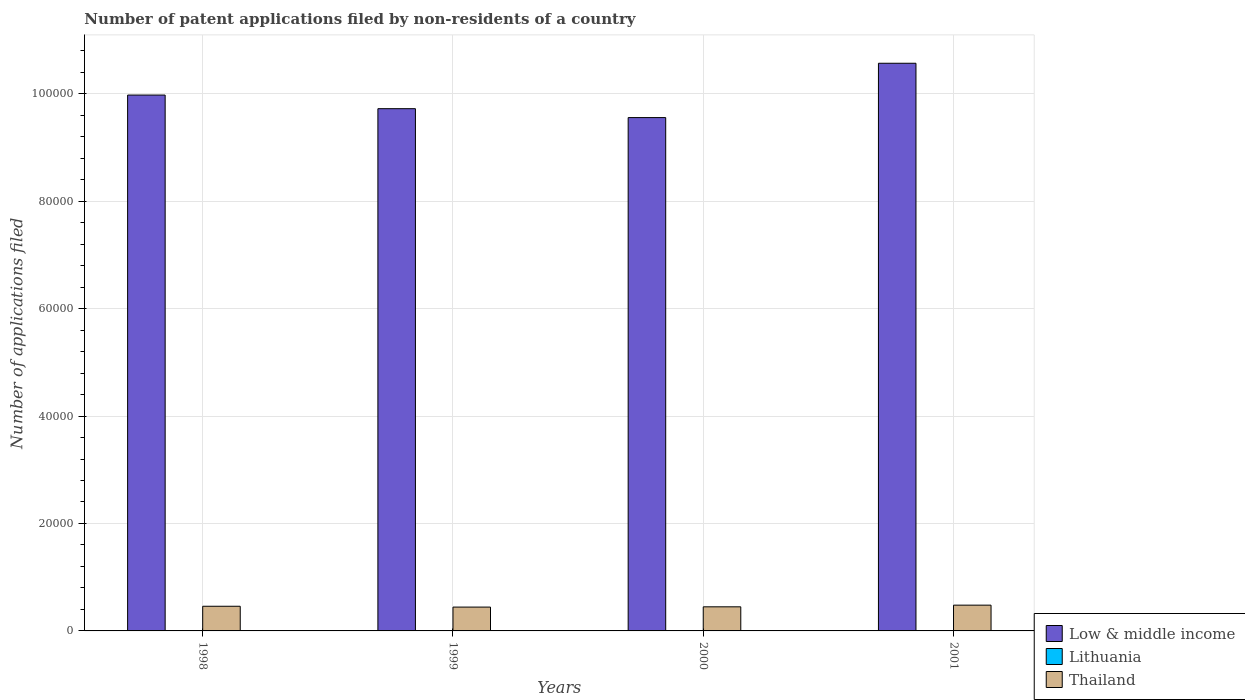How many different coloured bars are there?
Give a very brief answer. 3. What is the label of the 1st group of bars from the left?
Your answer should be very brief. 1998. What is the number of applications filed in Lithuania in 1999?
Your answer should be compact. 71. Across all years, what is the minimum number of applications filed in Low & middle income?
Give a very brief answer. 9.56e+04. In which year was the number of applications filed in Thailand minimum?
Keep it short and to the point. 1999. What is the total number of applications filed in Low & middle income in the graph?
Offer a terse response. 3.98e+05. What is the difference between the number of applications filed in Low & middle income in 1998 and that in 2000?
Offer a terse response. 4195. What is the difference between the number of applications filed in Lithuania in 2000 and the number of applications filed in Low & middle income in 2001?
Make the answer very short. -1.06e+05. What is the average number of applications filed in Thailand per year?
Make the answer very short. 4579. In the year 1999, what is the difference between the number of applications filed in Thailand and number of applications filed in Low & middle income?
Ensure brevity in your answer.  -9.28e+04. What is the ratio of the number of applications filed in Thailand in 1999 to that in 2000?
Offer a terse response. 0.99. Is the number of applications filed in Thailand in 1998 less than that in 2001?
Keep it short and to the point. Yes. Is the difference between the number of applications filed in Thailand in 1998 and 1999 greater than the difference between the number of applications filed in Low & middle income in 1998 and 1999?
Ensure brevity in your answer.  No. In how many years, is the number of applications filed in Thailand greater than the average number of applications filed in Thailand taken over all years?
Your answer should be compact. 2. Is the sum of the number of applications filed in Thailand in 1999 and 2000 greater than the maximum number of applications filed in Lithuania across all years?
Provide a short and direct response. Yes. What does the 2nd bar from the right in 1998 represents?
Offer a very short reply. Lithuania. Are all the bars in the graph horizontal?
Provide a short and direct response. No. Are the values on the major ticks of Y-axis written in scientific E-notation?
Provide a short and direct response. No. Does the graph contain any zero values?
Provide a succinct answer. No. Does the graph contain grids?
Provide a succinct answer. Yes. How many legend labels are there?
Provide a succinct answer. 3. What is the title of the graph?
Offer a very short reply. Number of patent applications filed by non-residents of a country. What is the label or title of the Y-axis?
Keep it short and to the point. Number of applications filed. What is the Number of applications filed of Low & middle income in 1998?
Your answer should be compact. 9.98e+04. What is the Number of applications filed in Lithuania in 1998?
Your answer should be compact. 71. What is the Number of applications filed of Thailand in 1998?
Your answer should be very brief. 4592. What is the Number of applications filed in Low & middle income in 1999?
Offer a terse response. 9.72e+04. What is the Number of applications filed of Thailand in 1999?
Provide a short and direct response. 4438. What is the Number of applications filed in Low & middle income in 2000?
Provide a succinct answer. 9.56e+04. What is the Number of applications filed in Lithuania in 2000?
Provide a short and direct response. 61. What is the Number of applications filed in Thailand in 2000?
Offer a terse response. 4488. What is the Number of applications filed in Low & middle income in 2001?
Your answer should be compact. 1.06e+05. What is the Number of applications filed in Lithuania in 2001?
Give a very brief answer. 55. What is the Number of applications filed of Thailand in 2001?
Keep it short and to the point. 4798. Across all years, what is the maximum Number of applications filed in Low & middle income?
Your answer should be compact. 1.06e+05. Across all years, what is the maximum Number of applications filed in Thailand?
Offer a terse response. 4798. Across all years, what is the minimum Number of applications filed of Low & middle income?
Provide a succinct answer. 9.56e+04. Across all years, what is the minimum Number of applications filed in Thailand?
Give a very brief answer. 4438. What is the total Number of applications filed in Low & middle income in the graph?
Your answer should be very brief. 3.98e+05. What is the total Number of applications filed of Lithuania in the graph?
Make the answer very short. 258. What is the total Number of applications filed in Thailand in the graph?
Provide a succinct answer. 1.83e+04. What is the difference between the Number of applications filed in Low & middle income in 1998 and that in 1999?
Make the answer very short. 2538. What is the difference between the Number of applications filed of Lithuania in 1998 and that in 1999?
Your answer should be very brief. 0. What is the difference between the Number of applications filed of Thailand in 1998 and that in 1999?
Give a very brief answer. 154. What is the difference between the Number of applications filed of Low & middle income in 1998 and that in 2000?
Provide a short and direct response. 4195. What is the difference between the Number of applications filed of Lithuania in 1998 and that in 2000?
Give a very brief answer. 10. What is the difference between the Number of applications filed in Thailand in 1998 and that in 2000?
Provide a short and direct response. 104. What is the difference between the Number of applications filed in Low & middle income in 1998 and that in 2001?
Provide a short and direct response. -5919. What is the difference between the Number of applications filed in Lithuania in 1998 and that in 2001?
Your answer should be very brief. 16. What is the difference between the Number of applications filed of Thailand in 1998 and that in 2001?
Your response must be concise. -206. What is the difference between the Number of applications filed in Low & middle income in 1999 and that in 2000?
Offer a very short reply. 1657. What is the difference between the Number of applications filed in Low & middle income in 1999 and that in 2001?
Keep it short and to the point. -8457. What is the difference between the Number of applications filed in Thailand in 1999 and that in 2001?
Your response must be concise. -360. What is the difference between the Number of applications filed in Low & middle income in 2000 and that in 2001?
Offer a very short reply. -1.01e+04. What is the difference between the Number of applications filed in Thailand in 2000 and that in 2001?
Provide a short and direct response. -310. What is the difference between the Number of applications filed in Low & middle income in 1998 and the Number of applications filed in Lithuania in 1999?
Provide a short and direct response. 9.97e+04. What is the difference between the Number of applications filed of Low & middle income in 1998 and the Number of applications filed of Thailand in 1999?
Offer a very short reply. 9.53e+04. What is the difference between the Number of applications filed in Lithuania in 1998 and the Number of applications filed in Thailand in 1999?
Ensure brevity in your answer.  -4367. What is the difference between the Number of applications filed of Low & middle income in 1998 and the Number of applications filed of Lithuania in 2000?
Offer a terse response. 9.97e+04. What is the difference between the Number of applications filed of Low & middle income in 1998 and the Number of applications filed of Thailand in 2000?
Make the answer very short. 9.53e+04. What is the difference between the Number of applications filed of Lithuania in 1998 and the Number of applications filed of Thailand in 2000?
Provide a short and direct response. -4417. What is the difference between the Number of applications filed in Low & middle income in 1998 and the Number of applications filed in Lithuania in 2001?
Keep it short and to the point. 9.97e+04. What is the difference between the Number of applications filed of Low & middle income in 1998 and the Number of applications filed of Thailand in 2001?
Make the answer very short. 9.50e+04. What is the difference between the Number of applications filed of Lithuania in 1998 and the Number of applications filed of Thailand in 2001?
Your answer should be compact. -4727. What is the difference between the Number of applications filed in Low & middle income in 1999 and the Number of applications filed in Lithuania in 2000?
Give a very brief answer. 9.72e+04. What is the difference between the Number of applications filed of Low & middle income in 1999 and the Number of applications filed of Thailand in 2000?
Offer a terse response. 9.27e+04. What is the difference between the Number of applications filed in Lithuania in 1999 and the Number of applications filed in Thailand in 2000?
Your answer should be compact. -4417. What is the difference between the Number of applications filed of Low & middle income in 1999 and the Number of applications filed of Lithuania in 2001?
Your answer should be very brief. 9.72e+04. What is the difference between the Number of applications filed in Low & middle income in 1999 and the Number of applications filed in Thailand in 2001?
Your response must be concise. 9.24e+04. What is the difference between the Number of applications filed of Lithuania in 1999 and the Number of applications filed of Thailand in 2001?
Offer a very short reply. -4727. What is the difference between the Number of applications filed of Low & middle income in 2000 and the Number of applications filed of Lithuania in 2001?
Provide a succinct answer. 9.55e+04. What is the difference between the Number of applications filed of Low & middle income in 2000 and the Number of applications filed of Thailand in 2001?
Provide a succinct answer. 9.08e+04. What is the difference between the Number of applications filed of Lithuania in 2000 and the Number of applications filed of Thailand in 2001?
Provide a succinct answer. -4737. What is the average Number of applications filed of Low & middle income per year?
Your answer should be very brief. 9.96e+04. What is the average Number of applications filed of Lithuania per year?
Your answer should be compact. 64.5. What is the average Number of applications filed in Thailand per year?
Give a very brief answer. 4579. In the year 1998, what is the difference between the Number of applications filed of Low & middle income and Number of applications filed of Lithuania?
Provide a succinct answer. 9.97e+04. In the year 1998, what is the difference between the Number of applications filed in Low & middle income and Number of applications filed in Thailand?
Your response must be concise. 9.52e+04. In the year 1998, what is the difference between the Number of applications filed in Lithuania and Number of applications filed in Thailand?
Your answer should be very brief. -4521. In the year 1999, what is the difference between the Number of applications filed in Low & middle income and Number of applications filed in Lithuania?
Keep it short and to the point. 9.71e+04. In the year 1999, what is the difference between the Number of applications filed of Low & middle income and Number of applications filed of Thailand?
Make the answer very short. 9.28e+04. In the year 1999, what is the difference between the Number of applications filed in Lithuania and Number of applications filed in Thailand?
Provide a short and direct response. -4367. In the year 2000, what is the difference between the Number of applications filed in Low & middle income and Number of applications filed in Lithuania?
Provide a succinct answer. 9.55e+04. In the year 2000, what is the difference between the Number of applications filed of Low & middle income and Number of applications filed of Thailand?
Make the answer very short. 9.11e+04. In the year 2000, what is the difference between the Number of applications filed in Lithuania and Number of applications filed in Thailand?
Your response must be concise. -4427. In the year 2001, what is the difference between the Number of applications filed in Low & middle income and Number of applications filed in Lithuania?
Offer a terse response. 1.06e+05. In the year 2001, what is the difference between the Number of applications filed in Low & middle income and Number of applications filed in Thailand?
Make the answer very short. 1.01e+05. In the year 2001, what is the difference between the Number of applications filed of Lithuania and Number of applications filed of Thailand?
Your answer should be very brief. -4743. What is the ratio of the Number of applications filed in Low & middle income in 1998 to that in 1999?
Your answer should be very brief. 1.03. What is the ratio of the Number of applications filed of Thailand in 1998 to that in 1999?
Your answer should be compact. 1.03. What is the ratio of the Number of applications filed in Low & middle income in 1998 to that in 2000?
Ensure brevity in your answer.  1.04. What is the ratio of the Number of applications filed of Lithuania in 1998 to that in 2000?
Ensure brevity in your answer.  1.16. What is the ratio of the Number of applications filed in Thailand in 1998 to that in 2000?
Your answer should be compact. 1.02. What is the ratio of the Number of applications filed in Low & middle income in 1998 to that in 2001?
Provide a short and direct response. 0.94. What is the ratio of the Number of applications filed of Lithuania in 1998 to that in 2001?
Provide a short and direct response. 1.29. What is the ratio of the Number of applications filed of Thailand in 1998 to that in 2001?
Offer a very short reply. 0.96. What is the ratio of the Number of applications filed in Low & middle income in 1999 to that in 2000?
Offer a terse response. 1.02. What is the ratio of the Number of applications filed of Lithuania in 1999 to that in 2000?
Your response must be concise. 1.16. What is the ratio of the Number of applications filed in Thailand in 1999 to that in 2000?
Provide a succinct answer. 0.99. What is the ratio of the Number of applications filed in Low & middle income in 1999 to that in 2001?
Make the answer very short. 0.92. What is the ratio of the Number of applications filed in Lithuania in 1999 to that in 2001?
Provide a short and direct response. 1.29. What is the ratio of the Number of applications filed of Thailand in 1999 to that in 2001?
Keep it short and to the point. 0.93. What is the ratio of the Number of applications filed in Low & middle income in 2000 to that in 2001?
Keep it short and to the point. 0.9. What is the ratio of the Number of applications filed in Lithuania in 2000 to that in 2001?
Make the answer very short. 1.11. What is the ratio of the Number of applications filed in Thailand in 2000 to that in 2001?
Keep it short and to the point. 0.94. What is the difference between the highest and the second highest Number of applications filed of Low & middle income?
Your response must be concise. 5919. What is the difference between the highest and the second highest Number of applications filed in Thailand?
Keep it short and to the point. 206. What is the difference between the highest and the lowest Number of applications filed of Low & middle income?
Provide a short and direct response. 1.01e+04. What is the difference between the highest and the lowest Number of applications filed of Thailand?
Give a very brief answer. 360. 